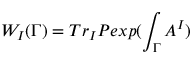Convert formula to latex. <formula><loc_0><loc_0><loc_500><loc_500>W _ { I } ( \Gamma ) = T r _ { I } P e x p ( \int _ { \Gamma } A ^ { I } )</formula> 